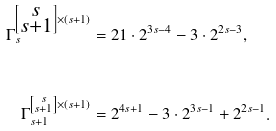Convert formula to latex. <formula><loc_0><loc_0><loc_500><loc_500>\Gamma _ { s } ^ { \left [ \substack { s \\ s + 1 } \right ] \times ( s + 1 ) } & = 2 1 \cdot 2 ^ { 3 s - 4 } - 3 \cdot 2 ^ { 2 s - 3 } , \\ & \\ \Gamma _ { s + 1 } ^ { \left [ \substack { s \\ s + 1 } \right ] \times ( s + 1 ) } & = 2 ^ { 4 s + 1 } - 3 \cdot 2 ^ { 3 s - 1 } + 2 ^ { 2 s - 1 } .</formula> 